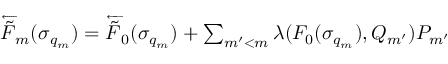<formula> <loc_0><loc_0><loc_500><loc_500>\begin{array} { r } { \overleftarrow { \tilde { F } } _ { m } ( \sigma _ { q _ { m } } ) = \overleftarrow { \tilde { F } } _ { 0 } ( \sigma _ { q _ { m } } ) + \sum _ { m ^ { \prime } < m } \lambda ( F _ { 0 } ( \sigma _ { q _ { m } } ) , Q _ { m ^ { \prime } } ) P _ { m ^ { \prime } } } \end{array}</formula> 